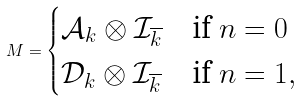<formula> <loc_0><loc_0><loc_500><loc_500>M = \begin{cases} \mathcal { A } _ { k } \otimes \mathcal { I } _ { \overline { k } } & \text {if $n=0$} \\ \mathcal { D } _ { k } \otimes \mathcal { I } _ { \overline { k } } & \text {if $n=1$} , \end{cases}</formula> 